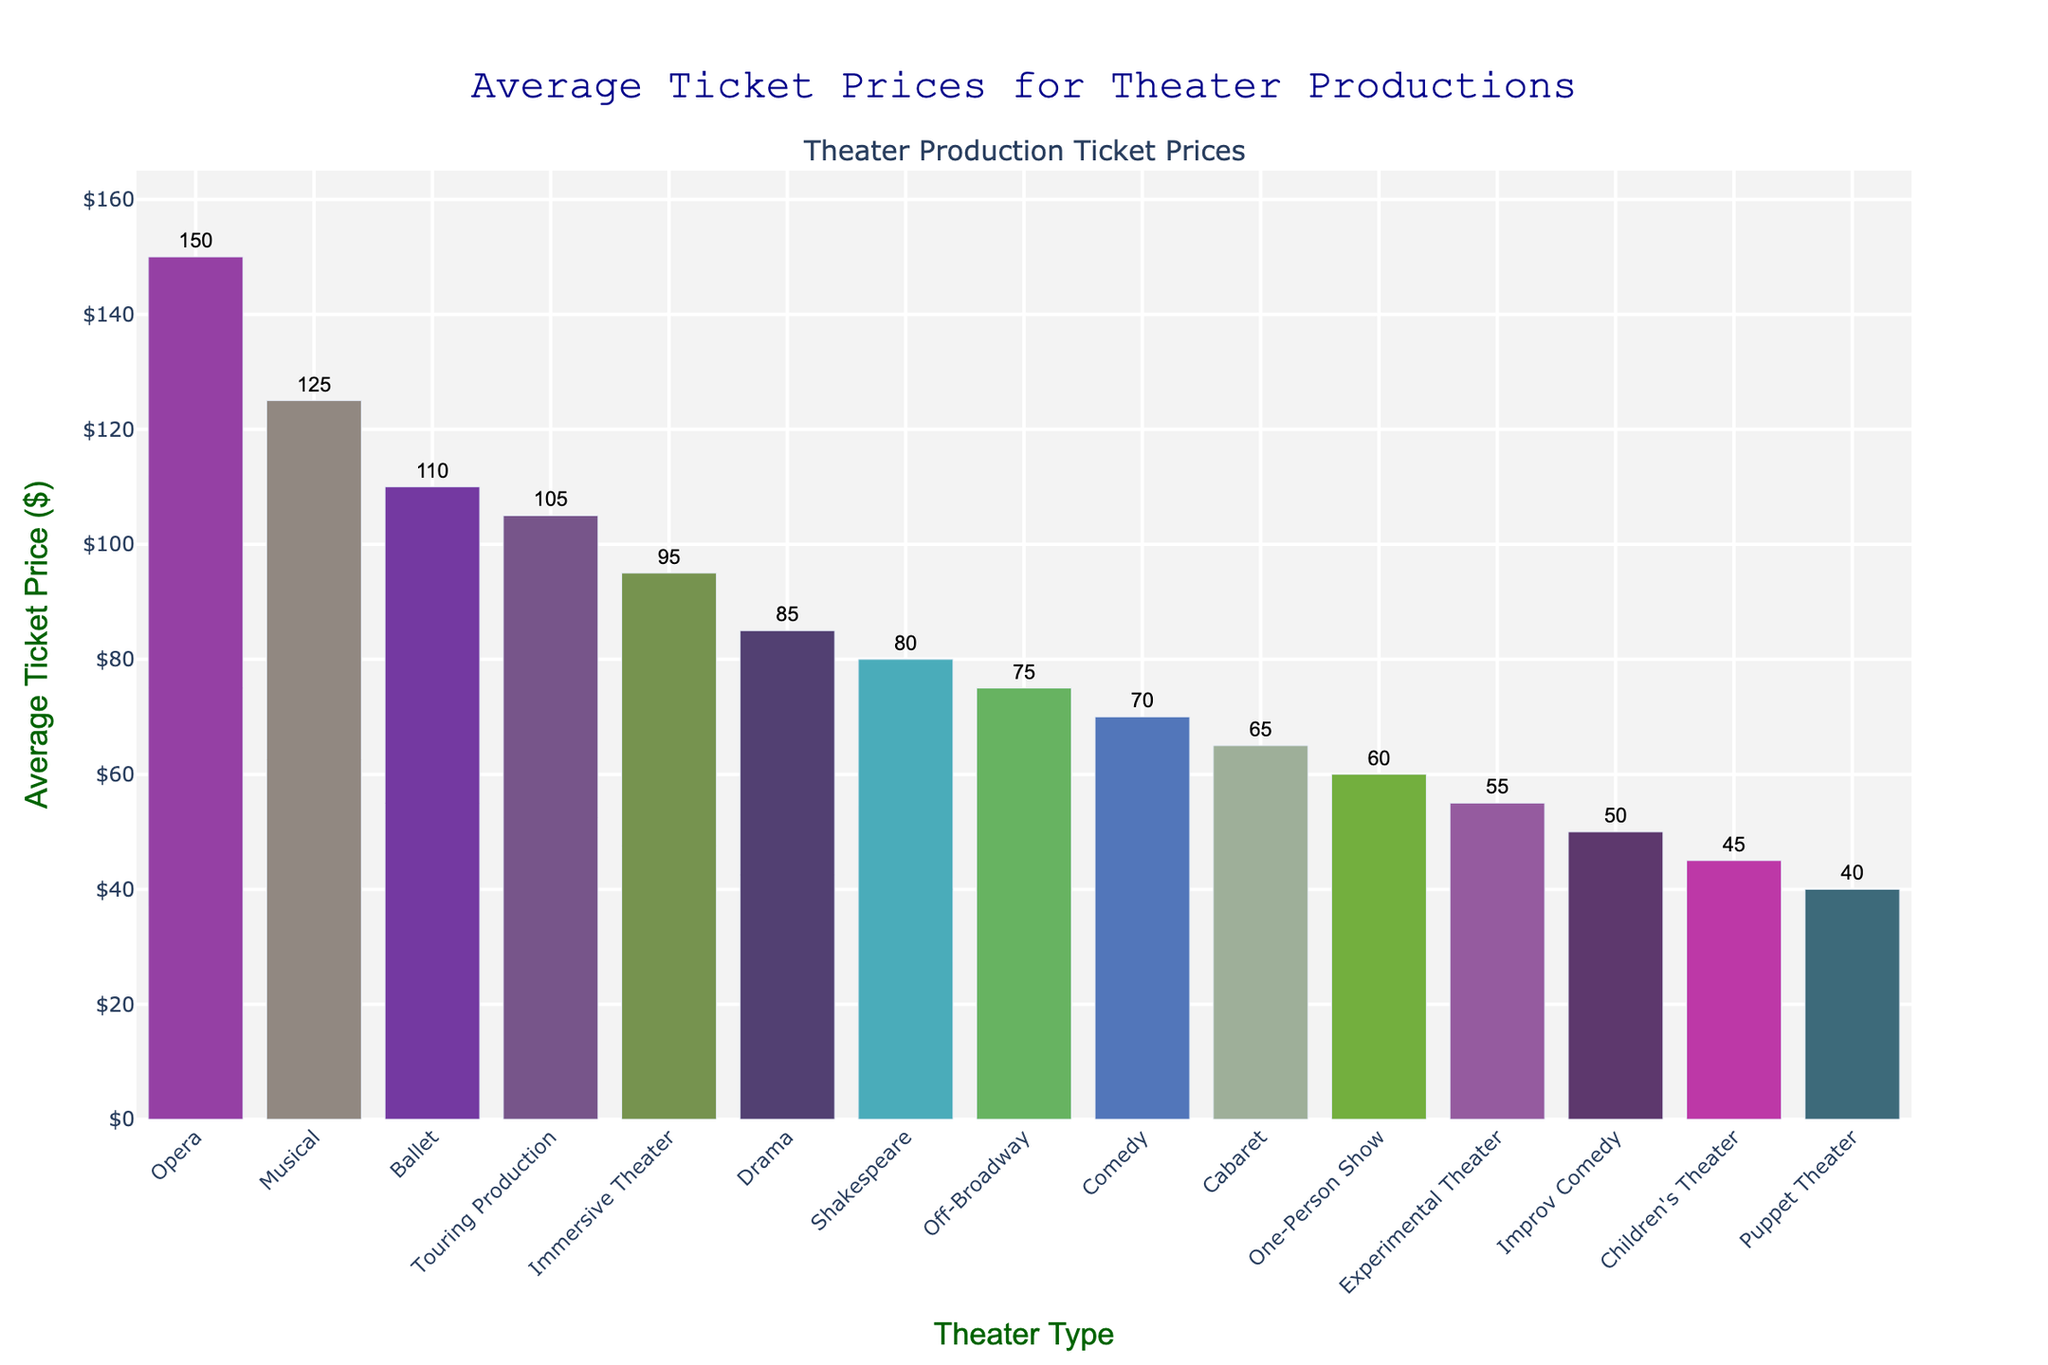Which type of theater production has the highest average ticket price? Find the bar with the greatest height, which represents the highest average ticket price. The label underneath identifies the theater type.
Answer: Opera Which theater types have an average ticket price of $55 or lower? Look for bars that have their top at or below the $55 mark on the y-axis and note their corresponding labels beneath.
Answer: Experimental Theater, Children's Theater, Puppet Theater, Improv Comedy Among Musical, Drama, and Comedy, which one has the least expensive average ticket price? Compare the heights of the bars for Musical, Drama, and Comedy. The shortest bar represents the least expensive ticket price.
Answer: Comedy What is the difference in average ticket price between Opera and Children's Theater? Find the heights of the Opera and Children's Theater bars. Subtract the value representing Children's Theater from the value representing Opera. $150 - $45 = $105
Answer: $105 Is the average ticket price of Immersive Theater more than double the price of Puppet Theater? Compare the height of the Immersive Theater bar to twice the height of the Puppet Theater bar. If the Immersive Theater bar is taller, the price is more than double. $95 > $80
Answer: Yes Which theater production types have average ticket prices ranging between $60 and $100? Identify the bars with heights between the $60 and $100 marks on the y-axis and note their corresponding labels beneath.
Answer: One-Person Show, Immersive Theater, Cabaret, Off-Broadway, Touring Production What is the average ticket price of Musical, and how does it compare to that of Ballet? Identify the heights of the Musical and Ballet bars and compare their values.
Answer: Musical: $125, Ballet: $110; Musical is $15 more expensive Do Children's Theater and Puppet Theater have very similar average ticket prices? Check the heights of the bars for Children's Theater and Puppet Theater and see if they are close in value. $45 for Children's Theater and $40 for Puppet Theater show a small difference.
Answer: Yes What is the total combined average ticket price for Comedy, Improv Comedy, and Cabaret? Sum the heights of the bars for Comedy, Improv Comedy, and Cabaret. $70 + $50 + $65 = $185
Answer: $185 What percentage of the average ticket price of Children's Theater is represented by Drama? Divide the height of the Drama bar by the height of the Children's Theater bar, then multiply by 100 to get the percentage. ($85/$45)*100 ≈ 188.89%
Answer: 188.89% 